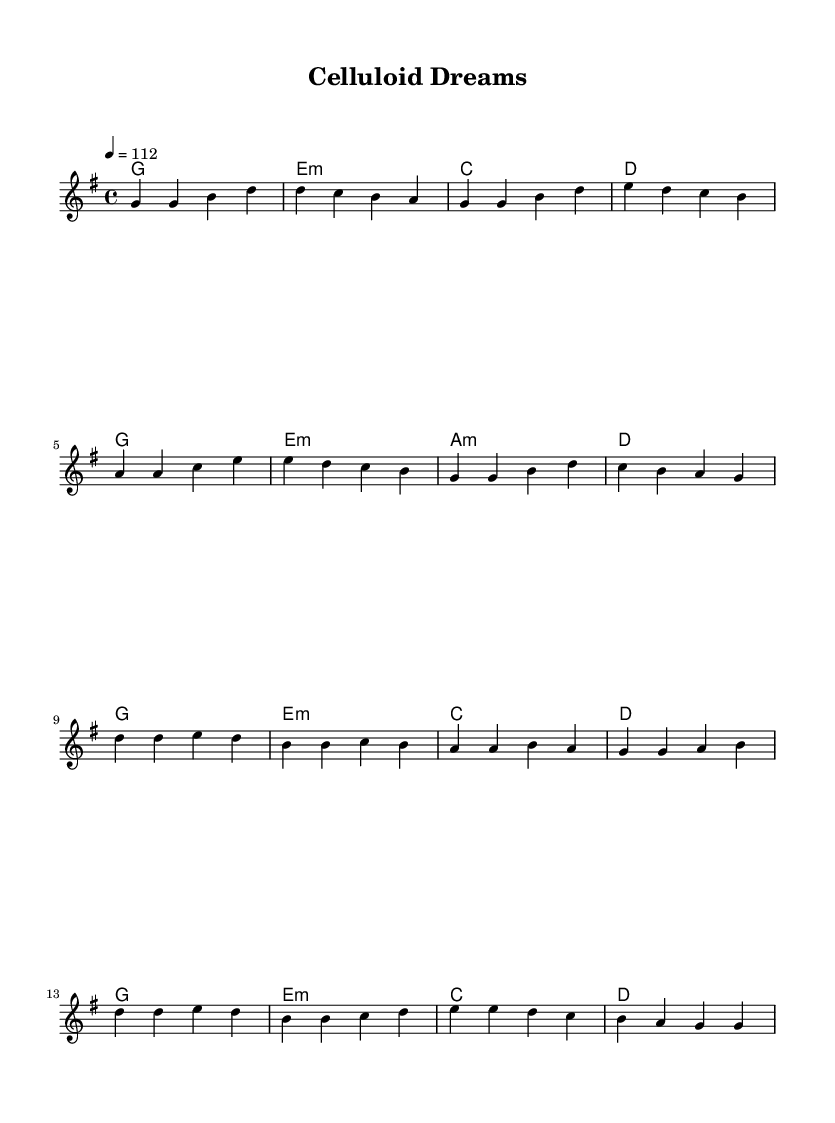What is the key signature of this music? The key signature is G major, indicated by one sharp (F#), which is shown at the beginning of the staff.
Answer: G major What is the time signature of this music? The time signature is 4/4, represented by two numbers at the beginning of the staff, indicating four beats per measure.
Answer: 4/4 What is the tempo marking of this music? The tempo marking is 112 beats per minute, specified by "4 = 112" at the beginning of the score.
Answer: 112 How many measures are in the verse section? The verse section comprises eight measures, as each line contains four measures and there are two lines for the verse.
Answer: 8 Which chord is used at the beginning of the chorus? The chorus begins with a G major chord, indicated at the start of the chorus section in the chordnames line.
Answer: G How does the melody in the chorus differ from the melody in the verse? The melody in the chorus features higher notes and a more dynamic movement, contrasting the more steady and lower notes in the verse.
Answer: Higher notes What type of musical structure is present in this piece? The piece follows a verse-chorus structure commonly found in K-Pop, alternating between the verse and chorus sections.
Answer: Verse-Chorus 